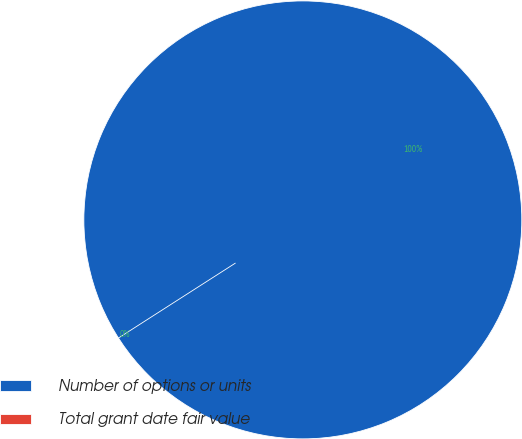Convert chart to OTSL. <chart><loc_0><loc_0><loc_500><loc_500><pie_chart><fcel>Number of options or units<fcel>Total grant date fair value<nl><fcel>100.0%<fcel>0.0%<nl></chart> 